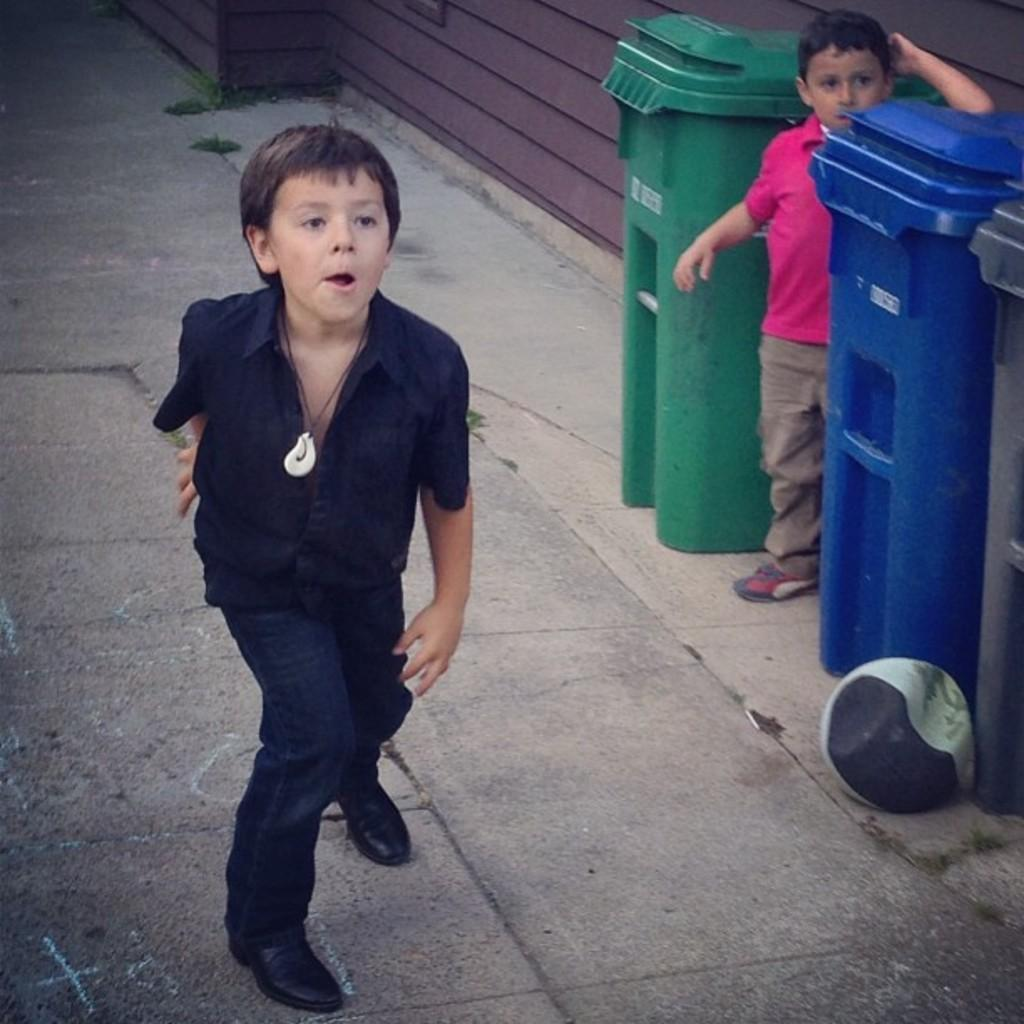What is the main subject in the center of the image? There is a boy standing in the center of the image. Where is the boy located in the image? The boy is standing on the road. Are there any other people in the image? Yes, there is another boy on the right side of the image. What objects can be seen on the right side of the image? Dustbins are present on the right side of the image. What is visible in the background of the image? There is a building in the background of the image. What type of chair is the boy sitting on in the image? There is no chair present in the image; the boy is standing on the road. 